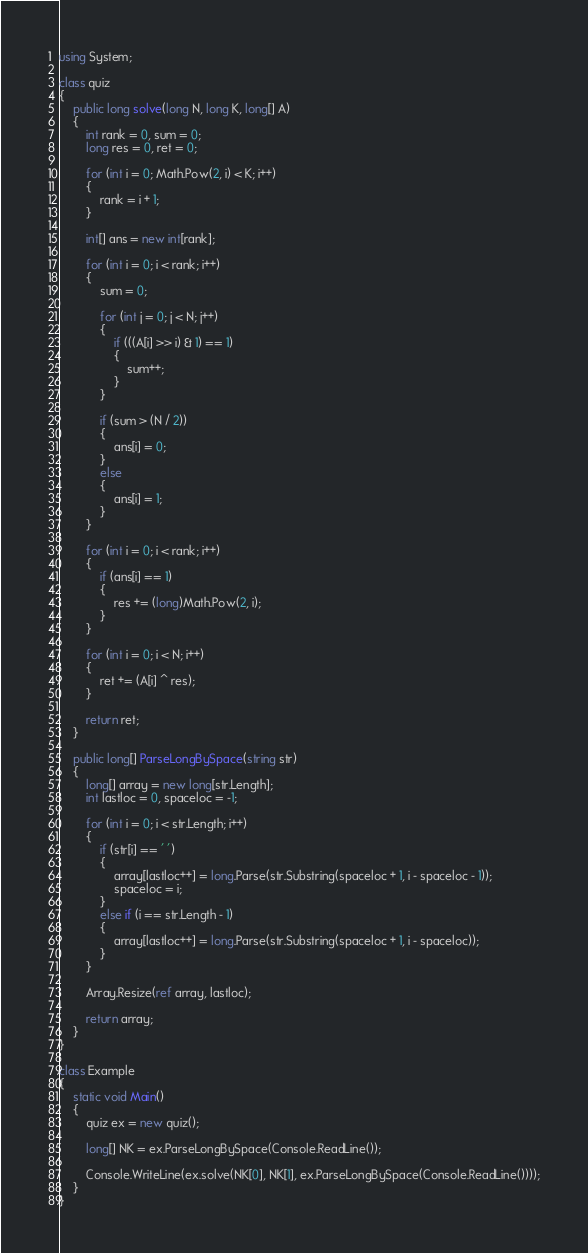Convert code to text. <code><loc_0><loc_0><loc_500><loc_500><_C#_>using System;

class quiz
{
    public long solve(long N, long K, long[] A)
    {
        int rank = 0, sum = 0;
        long res = 0, ret = 0;

        for (int i = 0; Math.Pow(2, i) < K; i++)
        {
            rank = i + 1;
        }

        int[] ans = new int[rank];

        for (int i = 0; i < rank; i++)
        {
            sum = 0;

            for (int j = 0; j < N; j++)
            {
                if (((A[i] >> i) & 1) == 1)
                {
                    sum++;
                }
            }

            if (sum > (N / 2))
            {
                ans[i] = 0;
            }
            else
            {
                ans[i] = 1;
            }
        }

        for (int i = 0; i < rank; i++)
        {
            if (ans[i] == 1)
            {
                res += (long)Math.Pow(2, i);
            }
        }

        for (int i = 0; i < N; i++)
        {
            ret += (A[i] ^ res);
        }

        return ret;
    }

    public long[] ParseLongBySpace(string str)
    {
        long[] array = new long[str.Length];
        int lastloc = 0, spaceloc = -1;

        for (int i = 0; i < str.Length; i++)
        {
            if (str[i] == ' ')
            {
                array[lastloc++] = long.Parse(str.Substring(spaceloc + 1, i - spaceloc - 1));
                spaceloc = i;
            }
            else if (i == str.Length - 1)
            {
                array[lastloc++] = long.Parse(str.Substring(spaceloc + 1, i - spaceloc));
            }
        }

        Array.Resize(ref array, lastloc);

        return array;
    }
}

class Example
{
    static void Main()
    {
        quiz ex = new quiz();

        long[] NK = ex.ParseLongBySpace(Console.ReadLine());

        Console.WriteLine(ex.solve(NK[0], NK[1], ex.ParseLongBySpace(Console.ReadLine())));
    }
}</code> 